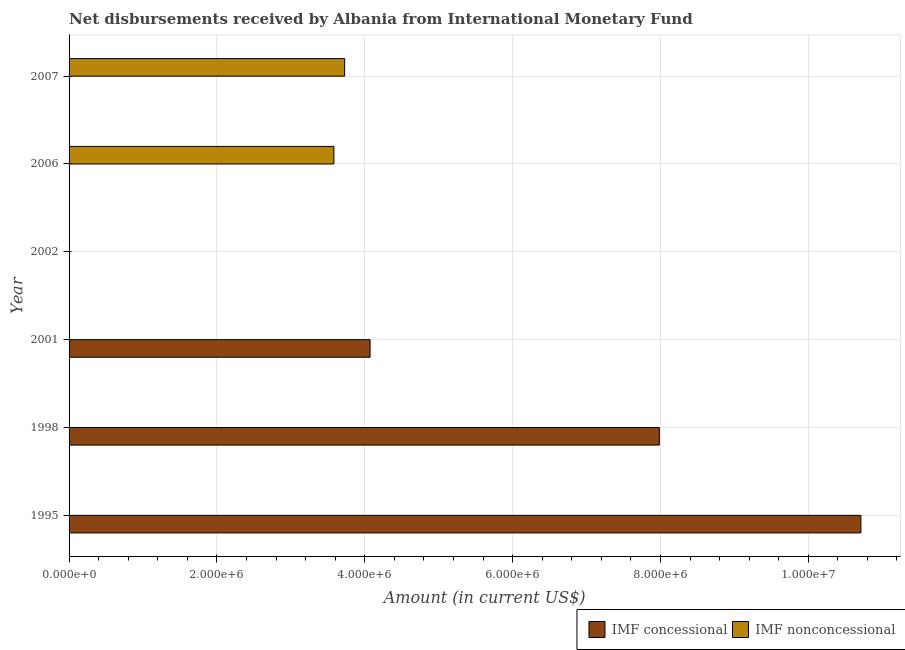How many different coloured bars are there?
Give a very brief answer. 2. Are the number of bars on each tick of the Y-axis equal?
Provide a short and direct response. No. How many bars are there on the 3rd tick from the top?
Provide a succinct answer. 0. In how many cases, is the number of bars for a given year not equal to the number of legend labels?
Keep it short and to the point. 6. What is the net non concessional disbursements from imf in 1998?
Your answer should be compact. 0. Across all years, what is the maximum net concessional disbursements from imf?
Provide a short and direct response. 1.07e+07. What is the total net concessional disbursements from imf in the graph?
Give a very brief answer. 2.28e+07. What is the difference between the net concessional disbursements from imf in 1995 and that in 2001?
Provide a short and direct response. 6.64e+06. What is the difference between the net concessional disbursements from imf in 2007 and the net non concessional disbursements from imf in 2001?
Offer a terse response. 0. What is the average net non concessional disbursements from imf per year?
Provide a succinct answer. 1.22e+06. What is the ratio of the net concessional disbursements from imf in 1995 to that in 2001?
Make the answer very short. 2.63. What is the difference between the highest and the second highest net concessional disbursements from imf?
Keep it short and to the point. 2.73e+06. What is the difference between the highest and the lowest net non concessional disbursements from imf?
Your answer should be very brief. 3.73e+06. How many years are there in the graph?
Provide a short and direct response. 6. What is the difference between two consecutive major ticks on the X-axis?
Keep it short and to the point. 2.00e+06. Are the values on the major ticks of X-axis written in scientific E-notation?
Provide a short and direct response. Yes. Does the graph contain any zero values?
Keep it short and to the point. Yes. Does the graph contain grids?
Your answer should be compact. Yes. Where does the legend appear in the graph?
Your answer should be very brief. Bottom right. How many legend labels are there?
Keep it short and to the point. 2. What is the title of the graph?
Provide a short and direct response. Net disbursements received by Albania from International Monetary Fund. What is the Amount (in current US$) of IMF concessional in 1995?
Provide a short and direct response. 1.07e+07. What is the Amount (in current US$) of IMF nonconcessional in 1995?
Provide a succinct answer. 0. What is the Amount (in current US$) in IMF concessional in 1998?
Your response must be concise. 7.98e+06. What is the Amount (in current US$) of IMF concessional in 2001?
Your answer should be compact. 4.07e+06. What is the Amount (in current US$) of IMF nonconcessional in 2001?
Keep it short and to the point. 0. What is the Amount (in current US$) in IMF concessional in 2002?
Your answer should be very brief. 0. What is the Amount (in current US$) in IMF concessional in 2006?
Ensure brevity in your answer.  0. What is the Amount (in current US$) of IMF nonconcessional in 2006?
Make the answer very short. 3.58e+06. What is the Amount (in current US$) of IMF concessional in 2007?
Offer a very short reply. 0. What is the Amount (in current US$) in IMF nonconcessional in 2007?
Your answer should be compact. 3.73e+06. Across all years, what is the maximum Amount (in current US$) in IMF concessional?
Offer a terse response. 1.07e+07. Across all years, what is the maximum Amount (in current US$) of IMF nonconcessional?
Give a very brief answer. 3.73e+06. Across all years, what is the minimum Amount (in current US$) of IMF concessional?
Your answer should be very brief. 0. Across all years, what is the minimum Amount (in current US$) in IMF nonconcessional?
Your response must be concise. 0. What is the total Amount (in current US$) of IMF concessional in the graph?
Make the answer very short. 2.28e+07. What is the total Amount (in current US$) in IMF nonconcessional in the graph?
Ensure brevity in your answer.  7.31e+06. What is the difference between the Amount (in current US$) in IMF concessional in 1995 and that in 1998?
Offer a terse response. 2.73e+06. What is the difference between the Amount (in current US$) in IMF concessional in 1995 and that in 2001?
Your response must be concise. 6.64e+06. What is the difference between the Amount (in current US$) of IMF concessional in 1998 and that in 2001?
Your response must be concise. 3.91e+06. What is the difference between the Amount (in current US$) in IMF nonconcessional in 2006 and that in 2007?
Keep it short and to the point. -1.45e+05. What is the difference between the Amount (in current US$) of IMF concessional in 1995 and the Amount (in current US$) of IMF nonconcessional in 2006?
Offer a terse response. 7.13e+06. What is the difference between the Amount (in current US$) in IMF concessional in 1995 and the Amount (in current US$) in IMF nonconcessional in 2007?
Your response must be concise. 6.98e+06. What is the difference between the Amount (in current US$) in IMF concessional in 1998 and the Amount (in current US$) in IMF nonconcessional in 2006?
Your answer should be very brief. 4.40e+06. What is the difference between the Amount (in current US$) in IMF concessional in 1998 and the Amount (in current US$) in IMF nonconcessional in 2007?
Give a very brief answer. 4.26e+06. What is the difference between the Amount (in current US$) in IMF concessional in 2001 and the Amount (in current US$) in IMF nonconcessional in 2006?
Offer a terse response. 4.89e+05. What is the difference between the Amount (in current US$) of IMF concessional in 2001 and the Amount (in current US$) of IMF nonconcessional in 2007?
Your response must be concise. 3.44e+05. What is the average Amount (in current US$) in IMF concessional per year?
Your response must be concise. 3.79e+06. What is the average Amount (in current US$) in IMF nonconcessional per year?
Give a very brief answer. 1.22e+06. What is the ratio of the Amount (in current US$) of IMF concessional in 1995 to that in 1998?
Your answer should be compact. 1.34. What is the ratio of the Amount (in current US$) in IMF concessional in 1995 to that in 2001?
Provide a succinct answer. 2.63. What is the ratio of the Amount (in current US$) in IMF concessional in 1998 to that in 2001?
Give a very brief answer. 1.96. What is the ratio of the Amount (in current US$) in IMF nonconcessional in 2006 to that in 2007?
Keep it short and to the point. 0.96. What is the difference between the highest and the second highest Amount (in current US$) in IMF concessional?
Give a very brief answer. 2.73e+06. What is the difference between the highest and the lowest Amount (in current US$) of IMF concessional?
Your answer should be compact. 1.07e+07. What is the difference between the highest and the lowest Amount (in current US$) in IMF nonconcessional?
Keep it short and to the point. 3.73e+06. 